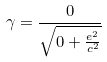Convert formula to latex. <formula><loc_0><loc_0><loc_500><loc_500>\gamma = \frac { 0 } { \sqrt { 0 + \frac { e ^ { 2 } } { c ^ { 2 } } } }</formula> 